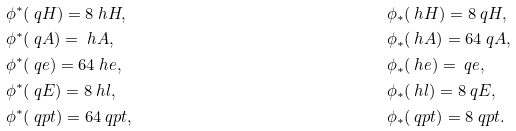Convert formula to latex. <formula><loc_0><loc_0><loc_500><loc_500>& \phi ^ { * } ( \ q H ) = 8 \ h H , & \quad & \phi _ { * } ( \ h H ) = 8 \ q H , \\ & \phi ^ { * } ( \ q A ) = \ h A , & \quad & \phi _ { * } ( \ h A ) = 6 4 \ q A , \\ & \phi ^ { * } ( \ q e ) = 6 4 \ h e , & \quad & \phi _ { * } ( \ h e ) = \ q e , \\ & \phi ^ { * } ( \ q E ) = 8 \ h l , & \quad & \phi _ { * } ( \ h l ) = 8 \ q E , \\ & \phi ^ { * } ( \ q p t ) = 6 4 \ q p t , & \quad & \phi _ { * } ( \ q p t ) = 8 \ q p t .</formula> 